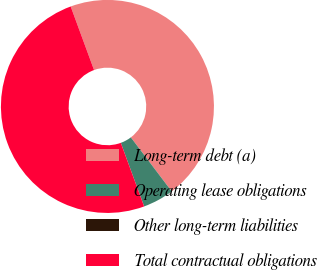<chart> <loc_0><loc_0><loc_500><loc_500><pie_chart><fcel>Long-term debt (a)<fcel>Operating lease obligations<fcel>Other long-term liabilities<fcel>Total contractual obligations<nl><fcel>45.3%<fcel>4.7%<fcel>0.01%<fcel>49.99%<nl></chart> 